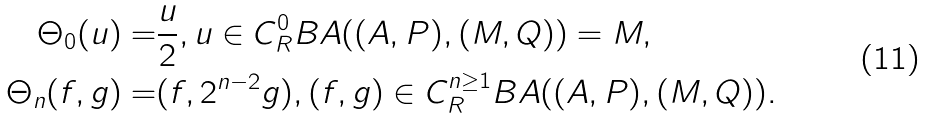<formula> <loc_0><loc_0><loc_500><loc_500>\Theta _ { 0 } ( u ) = & \frac { u } { 2 } , u \in C ^ { 0 } _ { R } B A ( ( A , P ) , ( M , Q ) ) = M , \\ \Theta _ { n } ( f , g ) = & ( f , 2 ^ { n - 2 } g ) , ( f , g ) \in C ^ { n \geq 1 } _ { R } B A ( ( A , P ) , ( M , Q ) ) .</formula> 